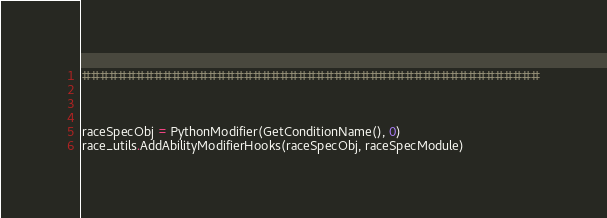<code> <loc_0><loc_0><loc_500><loc_500><_Python_>###################################################



raceSpecObj = PythonModifier(GetConditionName(), 0)
race_utils.AddAbilityModifierHooks(raceSpecObj, raceSpecModule)</code> 